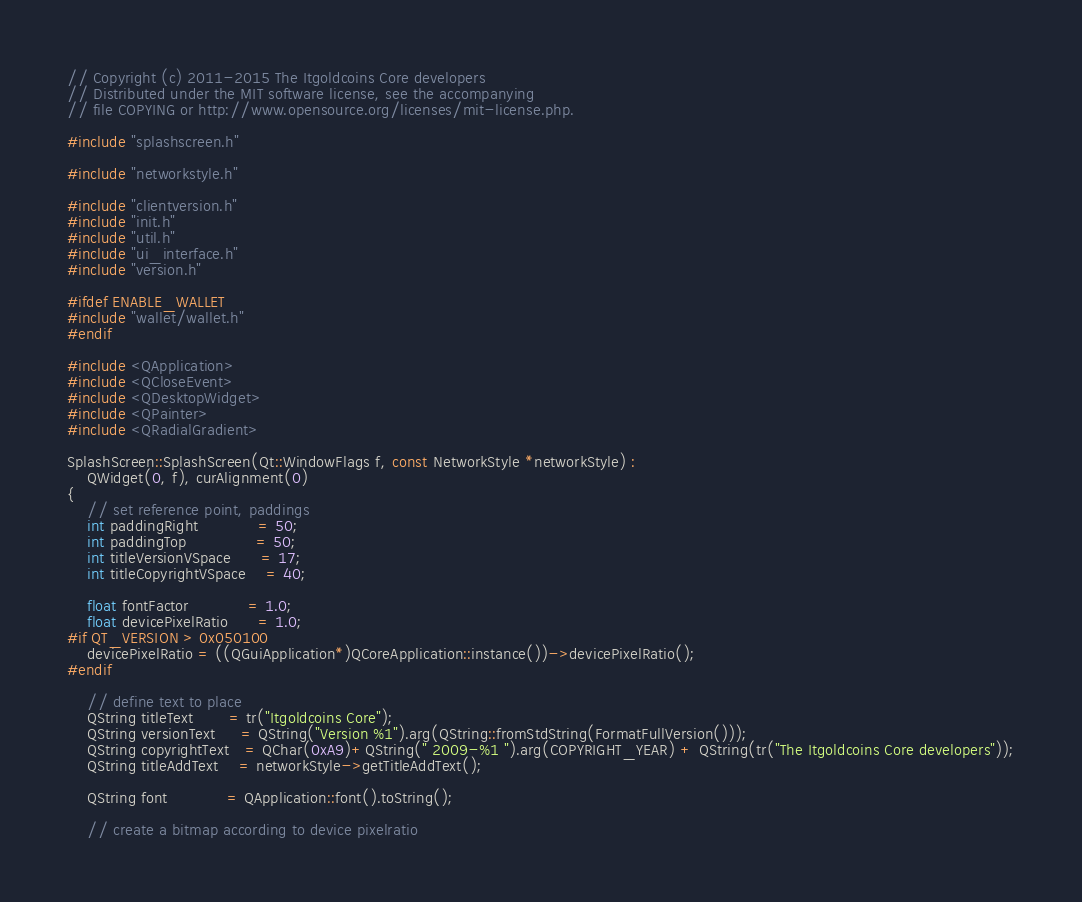<code> <loc_0><loc_0><loc_500><loc_500><_C++_>// Copyright (c) 2011-2015 The Itgoldcoins Core developers
// Distributed under the MIT software license, see the accompanying
// file COPYING or http://www.opensource.org/licenses/mit-license.php.

#include "splashscreen.h"

#include "networkstyle.h"

#include "clientversion.h"
#include "init.h"
#include "util.h"
#include "ui_interface.h"
#include "version.h"

#ifdef ENABLE_WALLET
#include "wallet/wallet.h"
#endif

#include <QApplication>
#include <QCloseEvent>
#include <QDesktopWidget>
#include <QPainter>
#include <QRadialGradient>

SplashScreen::SplashScreen(Qt::WindowFlags f, const NetworkStyle *networkStyle) :
    QWidget(0, f), curAlignment(0)
{
    // set reference point, paddings
    int paddingRight            = 50;
    int paddingTop              = 50;
    int titleVersionVSpace      = 17;
    int titleCopyrightVSpace    = 40;

    float fontFactor            = 1.0;
    float devicePixelRatio      = 1.0;
#if QT_VERSION > 0x050100
    devicePixelRatio = ((QGuiApplication*)QCoreApplication::instance())->devicePixelRatio();
#endif

    // define text to place
    QString titleText       = tr("Itgoldcoins Core");
    QString versionText     = QString("Version %1").arg(QString::fromStdString(FormatFullVersion()));
    QString copyrightText   = QChar(0xA9)+QString(" 2009-%1 ").arg(COPYRIGHT_YEAR) + QString(tr("The Itgoldcoins Core developers"));
    QString titleAddText    = networkStyle->getTitleAddText();

    QString font            = QApplication::font().toString();

    // create a bitmap according to device pixelratio</code> 